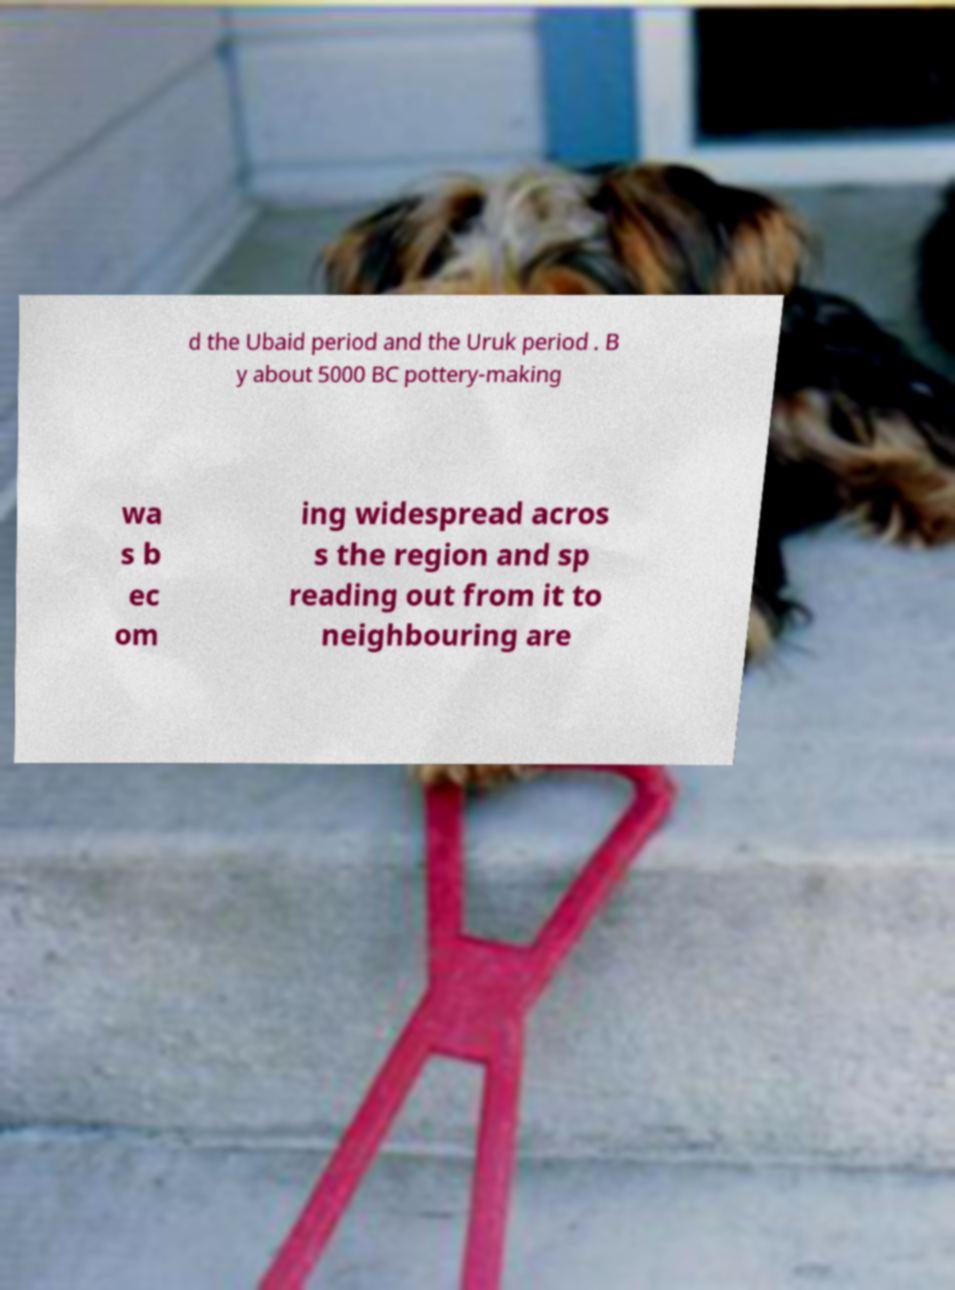I need the written content from this picture converted into text. Can you do that? d the Ubaid period and the Uruk period . B y about 5000 BC pottery-making wa s b ec om ing widespread acros s the region and sp reading out from it to neighbouring are 